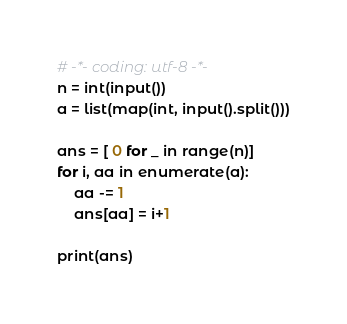Convert code to text. <code><loc_0><loc_0><loc_500><loc_500><_Python_># -*- coding: utf-8 -*-
n = int(input())
a = list(map(int, input().split()))

ans = [ 0 for _ in range(n)]
for i, aa in enumerate(a):
    aa -= 1
    ans[aa] = i+1

print(ans)</code> 